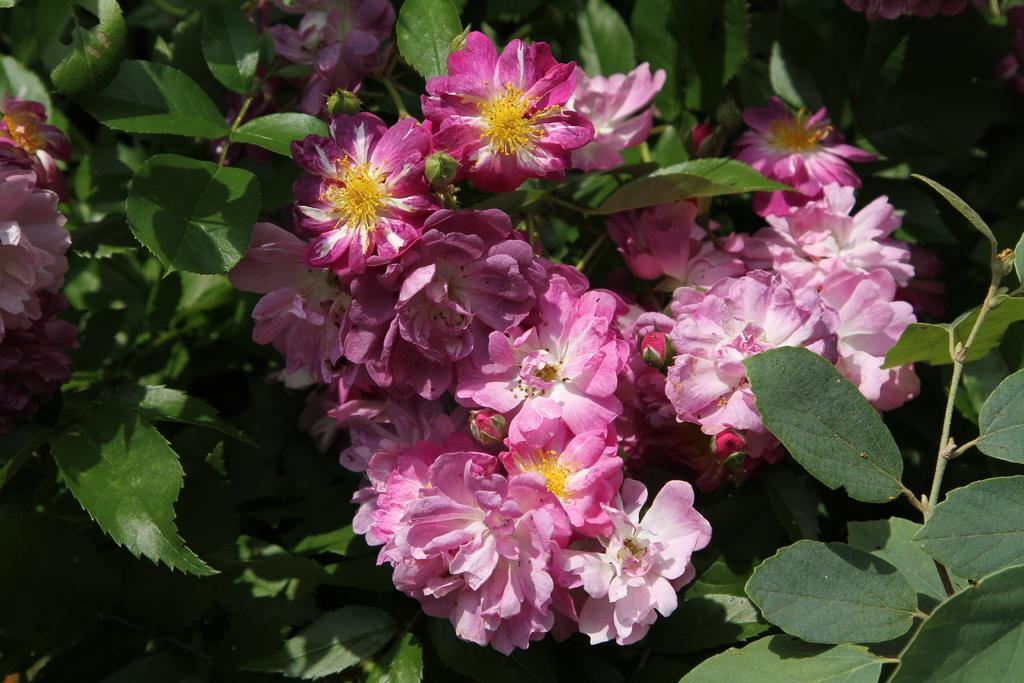What type of living organisms can be seen in the image? Plants can be seen in the image. What specific feature of the plants is visible in the image? The plants have flowers. What type of trousers are the plants wearing in the image? Plants do not wear trousers, as they are living organisms and not human beings. 